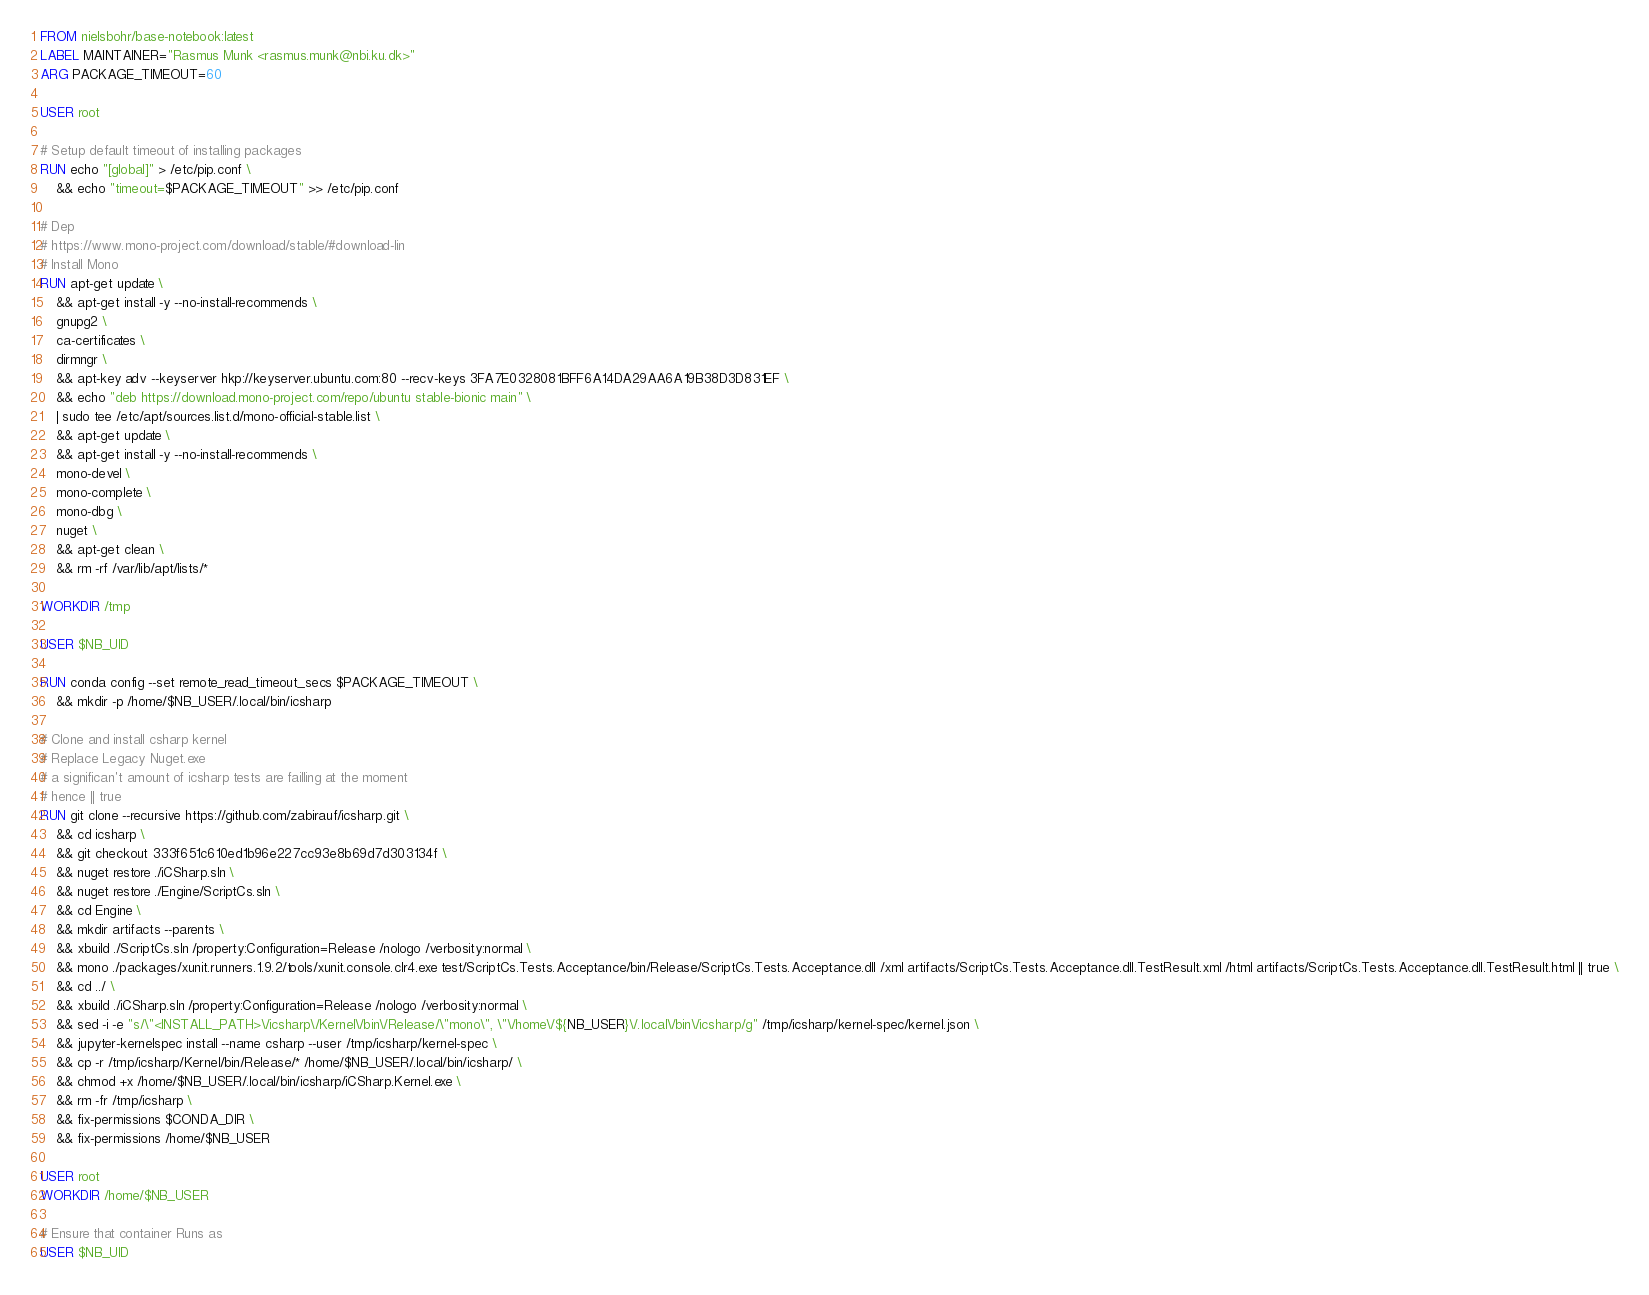Convert code to text. <code><loc_0><loc_0><loc_500><loc_500><_Dockerfile_>FROM nielsbohr/base-notebook:latest
LABEL MAINTAINER="Rasmus Munk <rasmus.munk@nbi.ku.dk>"
ARG PACKAGE_TIMEOUT=60

USER root

# Setup default timeout of installing packages
RUN echo "[global]" > /etc/pip.conf \
    && echo "timeout=$PACKAGE_TIMEOUT" >> /etc/pip.conf

# Dep
# https://www.mono-project.com/download/stable/#download-lin
# Install Mono
RUN apt-get update \
    && apt-get install -y --no-install-recommends \
    gnupg2 \
    ca-certificates \
    dirmngr \
    && apt-key adv --keyserver hkp://keyserver.ubuntu.com:80 --recv-keys 3FA7E0328081BFF6A14DA29AA6A19B38D3D831EF \
    && echo "deb https://download.mono-project.com/repo/ubuntu stable-bionic main" \
    | sudo tee /etc/apt/sources.list.d/mono-official-stable.list \
    && apt-get update \
    && apt-get install -y --no-install-recommends \
    mono-devel \
    mono-complete \
    mono-dbg \
    nuget \
    && apt-get clean \
    && rm -rf /var/lib/apt/lists/*

WORKDIR /tmp

USER $NB_UID

RUN conda config --set remote_read_timeout_secs $PACKAGE_TIMEOUT \
    && mkdir -p /home/$NB_USER/.local/bin/icsharp

# Clone and install csharp kernel
# Replace Legacy Nuget.exe
# a significan't amount of icsharp tests are failling at the moment
# hence || true
RUN git clone --recursive https://github.com/zabirauf/icsharp.git \
    && cd icsharp \
    && git checkout 333f651c610ed1b96e227cc93e8b69d7d303134f \
    && nuget restore ./iCSharp.sln \
    && nuget restore ./Engine/ScriptCs.sln \
    && cd Engine \
    && mkdir artifacts --parents \
    && xbuild ./ScriptCs.sln /property:Configuration=Release /nologo /verbosity:normal \
    && mono ./packages/xunit.runners.1.9.2/tools/xunit.console.clr4.exe test/ScriptCs.Tests.Acceptance/bin/Release/ScriptCs.Tests.Acceptance.dll /xml artifacts/ScriptCs.Tests.Acceptance.dll.TestResult.xml /html artifacts/ScriptCs.Tests.Acceptance.dll.TestResult.html || true \
    && cd ../ \
    && xbuild ./iCSharp.sln /property:Configuration=Release /nologo /verbosity:normal \
    && sed -i -e "s/\"<INSTALL_PATH>\/icsharp\/Kernel\/bin\/Release/\"mono\", \"\/home\/${NB_USER}\/.local\/bin\/icsharp/g" /tmp/icsharp/kernel-spec/kernel.json \
    && jupyter-kernelspec install --name csharp --user /tmp/icsharp/kernel-spec \
    && cp -r /tmp/icsharp/Kernel/bin/Release/* /home/$NB_USER/.local/bin/icsharp/ \
    && chmod +x /home/$NB_USER/.local/bin/icsharp/iCSharp.Kernel.exe \
    && rm -fr /tmp/icsharp \
    && fix-permissions $CONDA_DIR \
    && fix-permissions /home/$NB_USER

USER root
WORKDIR /home/$NB_USER

# Ensure that container Runs as
USER $NB_UID
</code> 